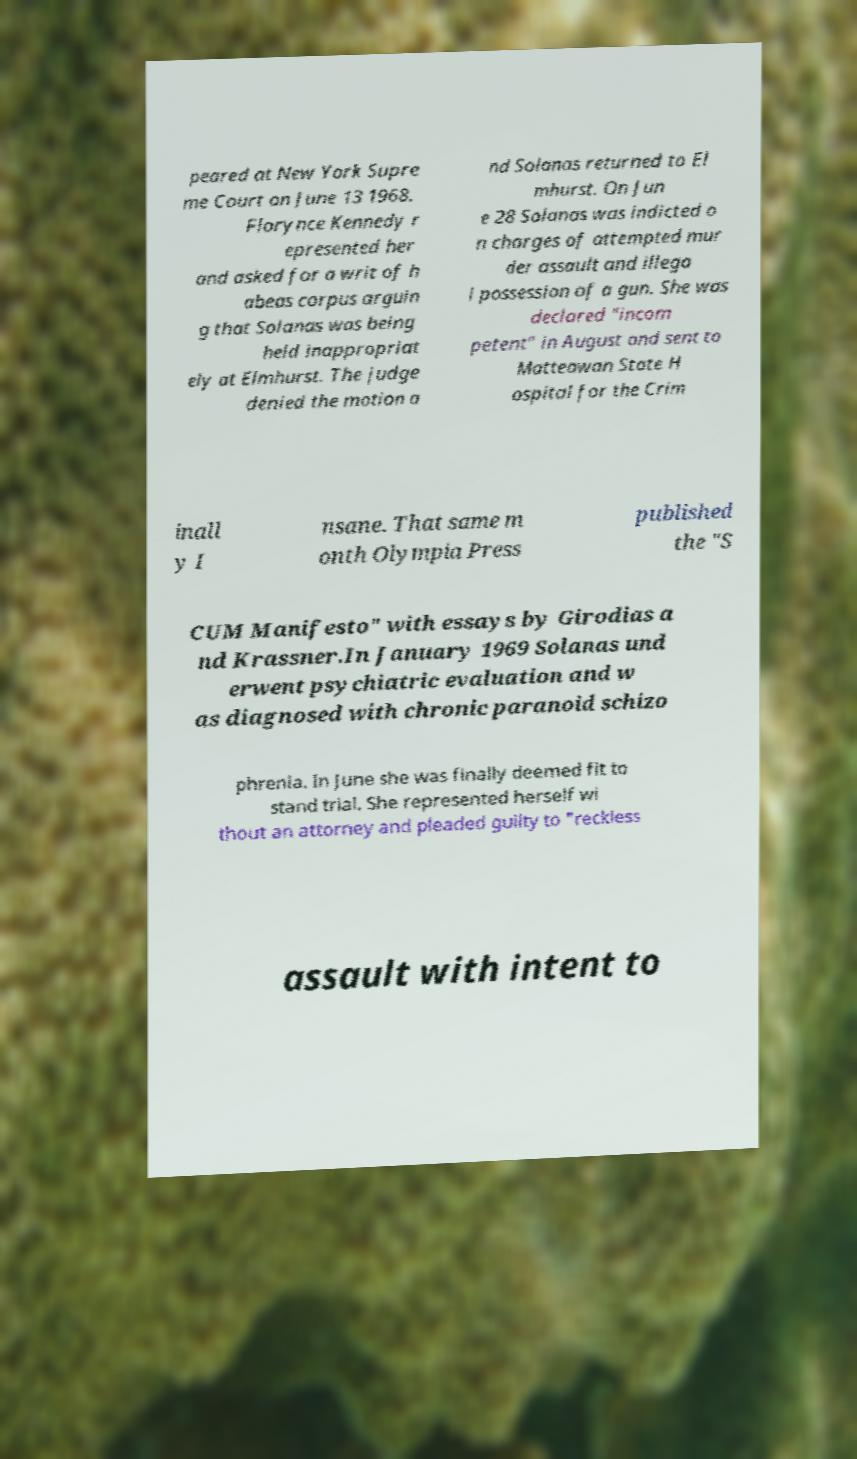Could you assist in decoding the text presented in this image and type it out clearly? peared at New York Supre me Court on June 13 1968. Florynce Kennedy r epresented her and asked for a writ of h abeas corpus arguin g that Solanas was being held inappropriat ely at Elmhurst. The judge denied the motion a nd Solanas returned to El mhurst. On Jun e 28 Solanas was indicted o n charges of attempted mur der assault and illega l possession of a gun. She was declared "incom petent" in August and sent to Matteawan State H ospital for the Crim inall y I nsane. That same m onth Olympia Press published the "S CUM Manifesto" with essays by Girodias a nd Krassner.In January 1969 Solanas und erwent psychiatric evaluation and w as diagnosed with chronic paranoid schizo phrenia. In June she was finally deemed fit to stand trial. She represented herself wi thout an attorney and pleaded guilty to "reckless assault with intent to 